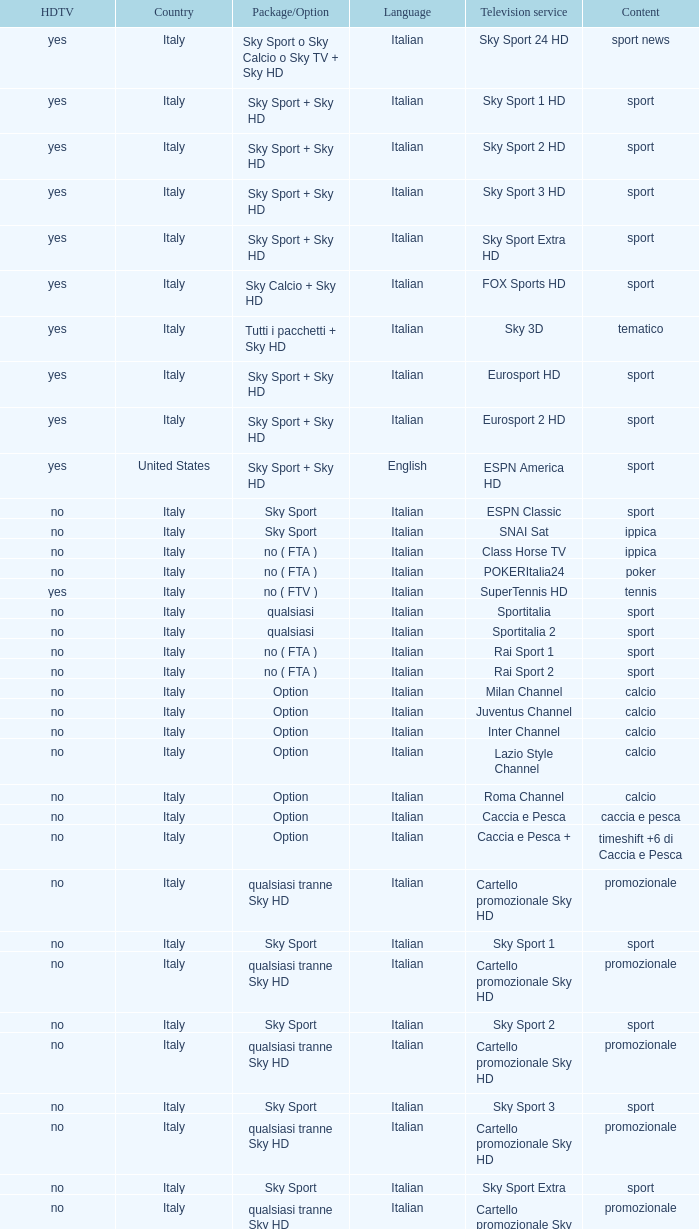What is Language, when Content is Sport, when HDTV is No, and when Television Service is ESPN America? Italian. 